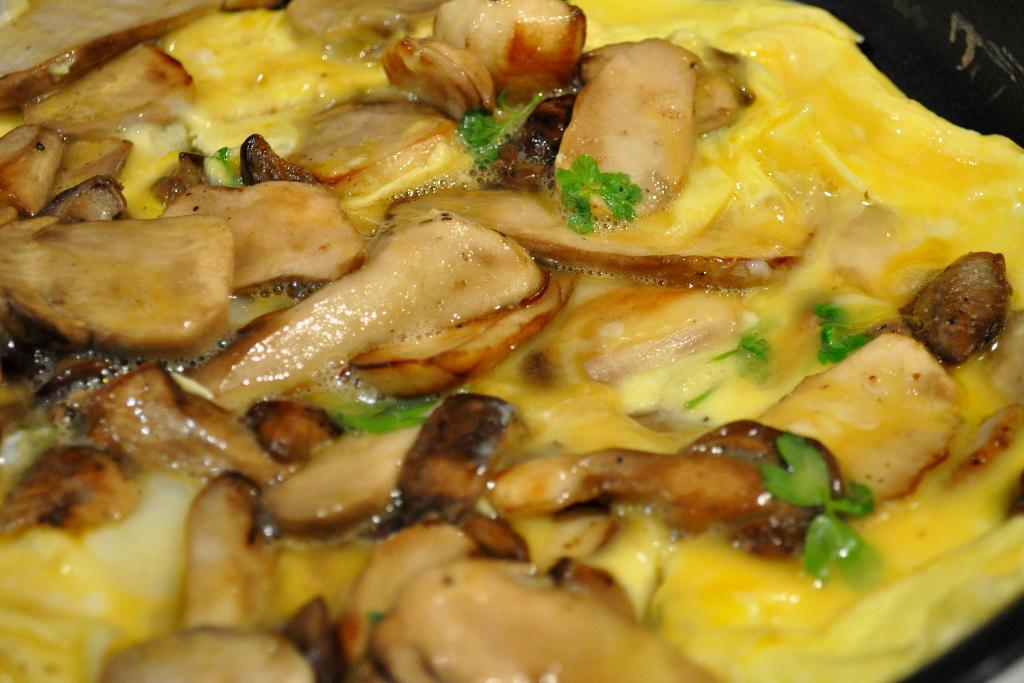What type of food can be seen in the image? The image contains food, but the specific type cannot be determined from the provided facts. What colors are present in the food? The food has yellow, green, and cream colors. How does the rainstorm affect the food in the image? There is no rainstorm present in the image, so it cannot affect the food. What type of attraction is near the food in the image? The provided facts do not mention any attractions near the food, so we cannot determine if there is any attraction present. 